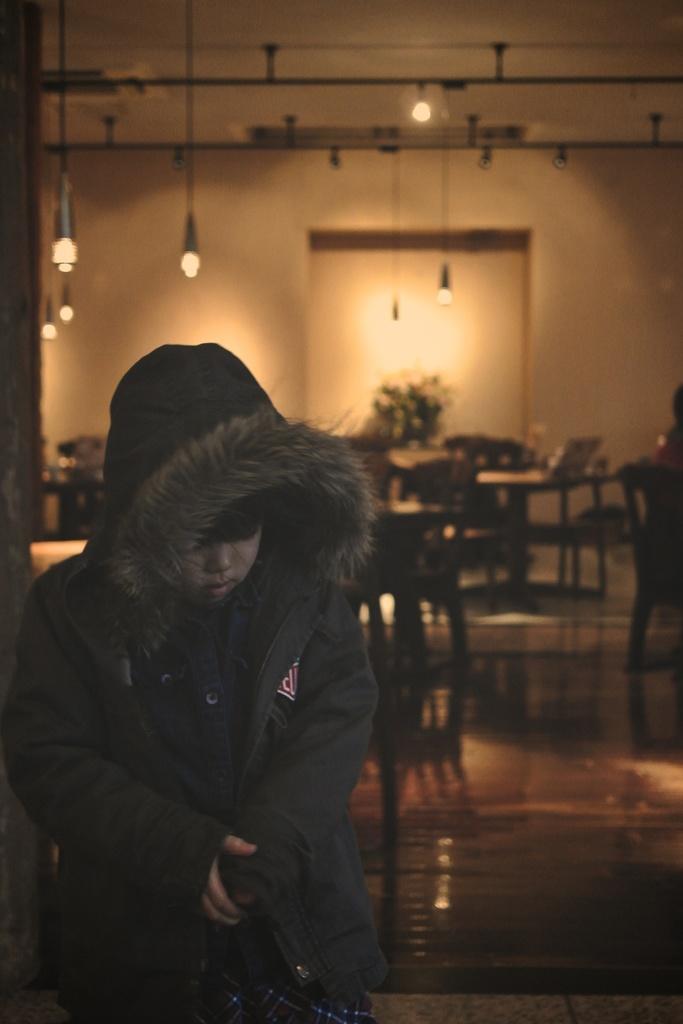In one or two sentences, can you explain what this image depicts? In this image I can see a boy and I can see he is wearing a jacket. In the background I can see few tables, few chairs, number of lights and I can see this image is little bit blurry from background. 